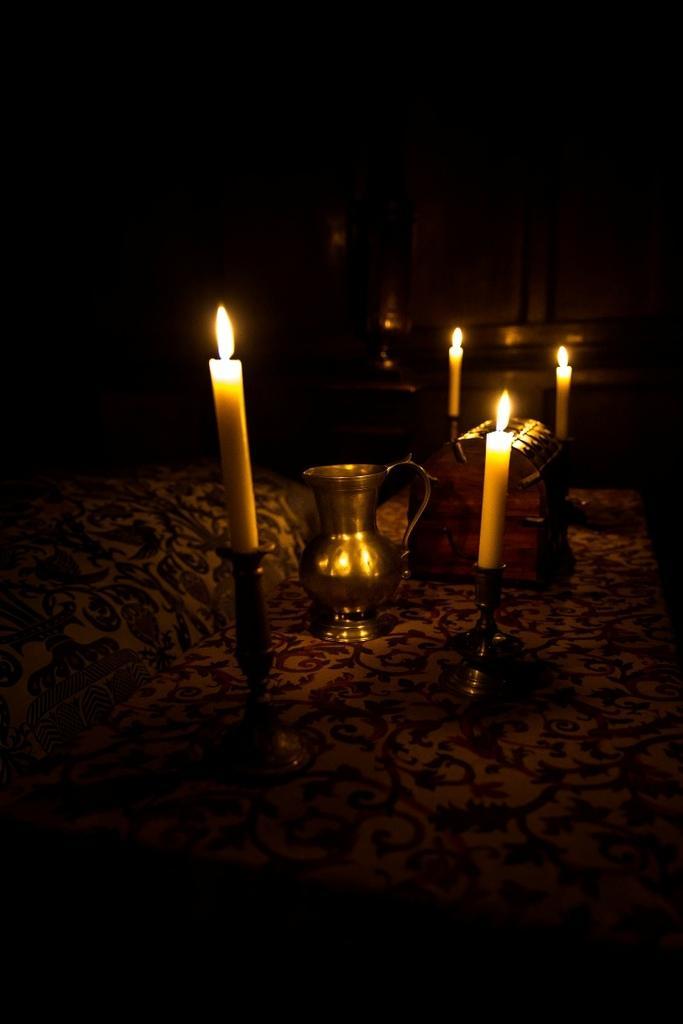Could you give a brief overview of what you see in this image? In this image I see 4 candles and I see a jug over here and it is dark in the background. 